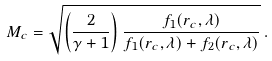<formula> <loc_0><loc_0><loc_500><loc_500>M _ { c } = \sqrt { \left ( { \frac { 2 } { \gamma + 1 } } \right ) \frac { { f _ { 1 } } ( r _ { c } , \lambda ) } { { { f _ { 1 } } ( r _ { c } , \lambda ) } + { { f _ { 2 } } ( r _ { c } , \lambda ) } } } \, .</formula> 